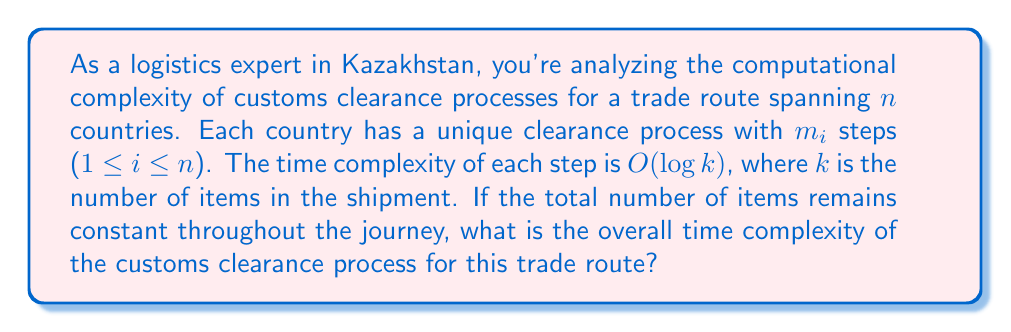Teach me how to tackle this problem. To determine the overall time complexity, we need to analyze the process step-by-step:

1. For each country $i$, there are $m_i$ steps in the clearance process.

2. Each step has a time complexity of $O(\log k)$, where $k$ is the number of items.

3. The total number of steps across all countries is the sum of all $m_i$:

   $$M = \sum_{i=1}^n m_i$$

4. Since each step takes $O(\log k)$ time, and we have $M$ total steps, the overall time complexity is:

   $$O(M \cdot \log k)$$

5. Substituting the sum for $M$:

   $$O\left(\left(\sum_{i=1}^n m_i\right) \cdot \log k\right)$$

6. The summation $\sum_{i=1}^n m_i$ is bounded by $O(n \cdot m_{max})$, where $m_{max}$ is the maximum number of steps in any country's process.

7. Therefore, we can express the final time complexity as:

   $$O(n \cdot m_{max} \cdot \log k)$$

This represents the worst-case scenario where each country has the maximum number of steps $m_{max}$ in its clearance process.
Answer: $O(n \cdot m_{max} \cdot \log k)$, where $n$ is the number of countries, $m_{max}$ is the maximum number of steps in any country's clearance process, and $k$ is the number of items in the shipment. 